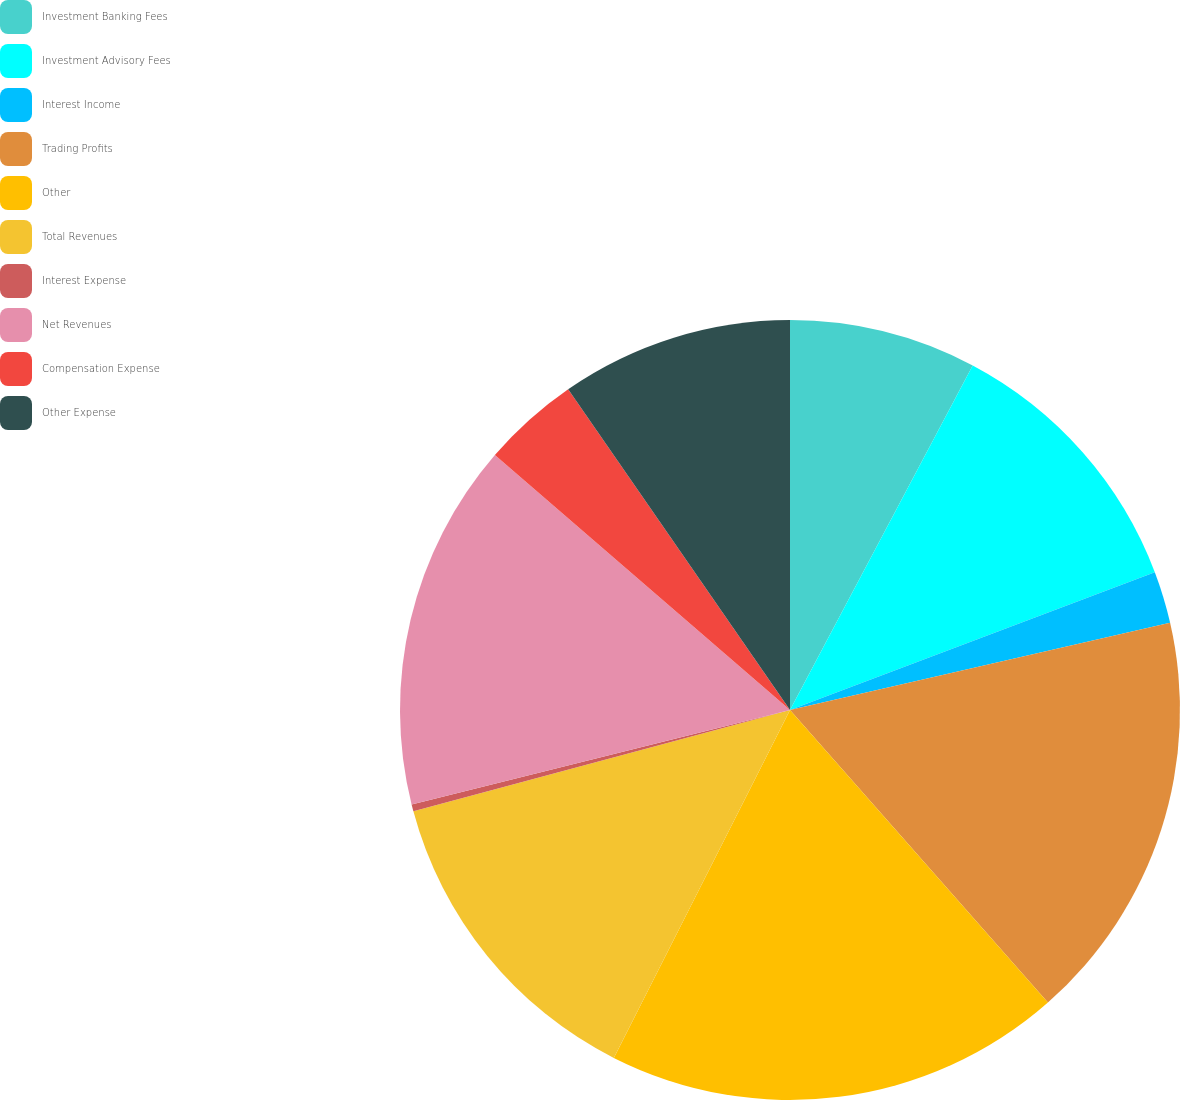<chart> <loc_0><loc_0><loc_500><loc_500><pie_chart><fcel>Investment Banking Fees<fcel>Investment Advisory Fees<fcel>Interest Income<fcel>Trading Profits<fcel>Other<fcel>Total Revenues<fcel>Interest Expense<fcel>Net Revenues<fcel>Compensation Expense<fcel>Other Expense<nl><fcel>7.76%<fcel>11.49%<fcel>2.16%<fcel>17.09%<fcel>18.96%<fcel>13.36%<fcel>0.29%<fcel>15.23%<fcel>4.03%<fcel>9.63%<nl></chart> 